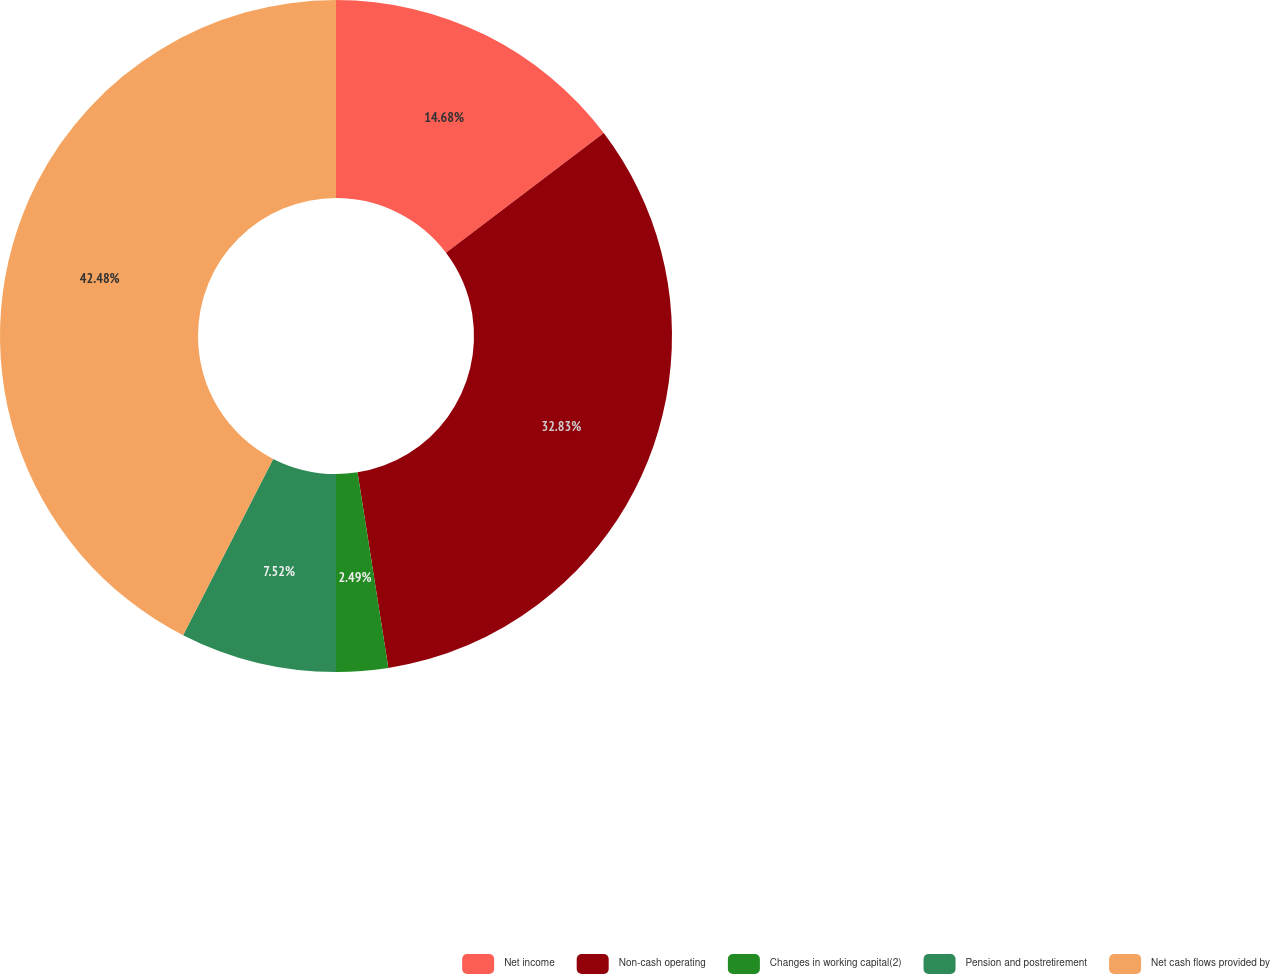Convert chart. <chart><loc_0><loc_0><loc_500><loc_500><pie_chart><fcel>Net income<fcel>Non-cash operating<fcel>Changes in working capital(2)<fcel>Pension and postretirement<fcel>Net cash flows provided by<nl><fcel>14.68%<fcel>32.83%<fcel>2.49%<fcel>7.52%<fcel>42.48%<nl></chart> 